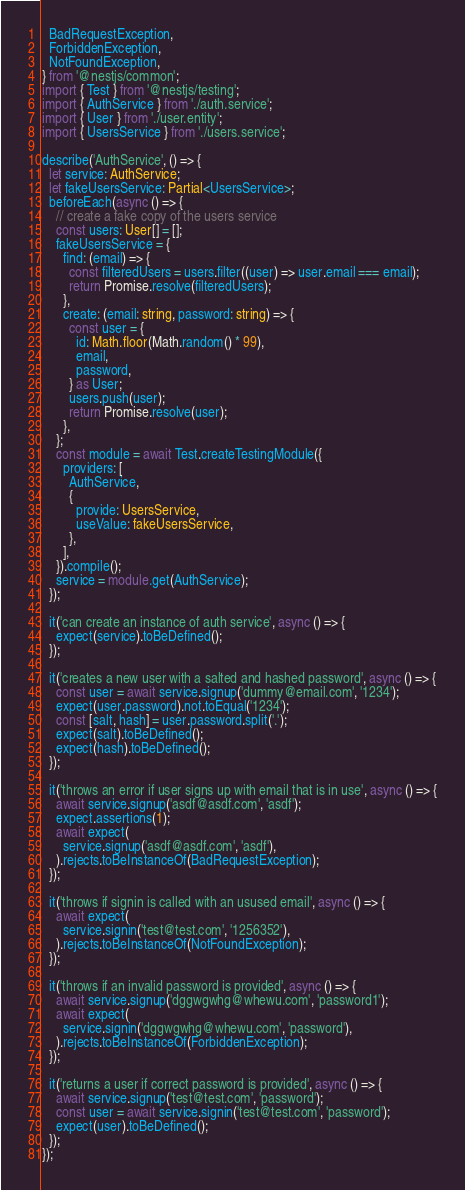<code> <loc_0><loc_0><loc_500><loc_500><_TypeScript_>  BadRequestException,
  ForbiddenException,
  NotFoundException,
} from '@nestjs/common';
import { Test } from '@nestjs/testing';
import { AuthService } from './auth.service';
import { User } from './user.entity';
import { UsersService } from './users.service';

describe('AuthService', () => {
  let service: AuthService;
  let fakeUsersService: Partial<UsersService>;
  beforeEach(async () => {
    // create a fake copy of the users service
    const users: User[] = [];
    fakeUsersService = {
      find: (email) => {
        const filteredUsers = users.filter((user) => user.email === email);
        return Promise.resolve(filteredUsers);
      },
      create: (email: string, password: string) => {
        const user = {
          id: Math.floor(Math.random() * 99),
          email,
          password,
        } as User;
        users.push(user);
        return Promise.resolve(user);
      },
    };
    const module = await Test.createTestingModule({
      providers: [
        AuthService,
        {
          provide: UsersService,
          useValue: fakeUsersService,
        },
      ],
    }).compile();
    service = module.get(AuthService);
  });

  it('can create an instance of auth service', async () => {
    expect(service).toBeDefined();
  });

  it('creates a new user with a salted and hashed password', async () => {
    const user = await service.signup('dummy@email.com', '1234');
    expect(user.password).not.toEqual('1234');
    const [salt, hash] = user.password.split('.');
    expect(salt).toBeDefined();
    expect(hash).toBeDefined();
  });

  it('throws an error if user signs up with email that is in use', async () => {
    await service.signup('asdf@asdf.com', 'asdf');
    expect.assertions(1);
    await expect(
      service.signup('asdf@asdf.com', 'asdf'),
    ).rejects.toBeInstanceOf(BadRequestException);
  });

  it('throws if signin is called with an usused email', async () => {
    await expect(
      service.signin('test@test.com', '1256352'),
    ).rejects.toBeInstanceOf(NotFoundException);
  });

  it('throws if an invalid password is provided', async () => {
    await service.signup('dggwgwhg@whewu.com', 'password1');
    await expect(
      service.signin('dggwgwhg@whewu.com', 'password'),
    ).rejects.toBeInstanceOf(ForbiddenException);
  });

  it('returns a user if correct password is provided', async () => {
    await service.signup('test@test.com', 'password');
    const user = await service.signin('test@test.com', 'password');
    expect(user).toBeDefined();
  });
});
</code> 